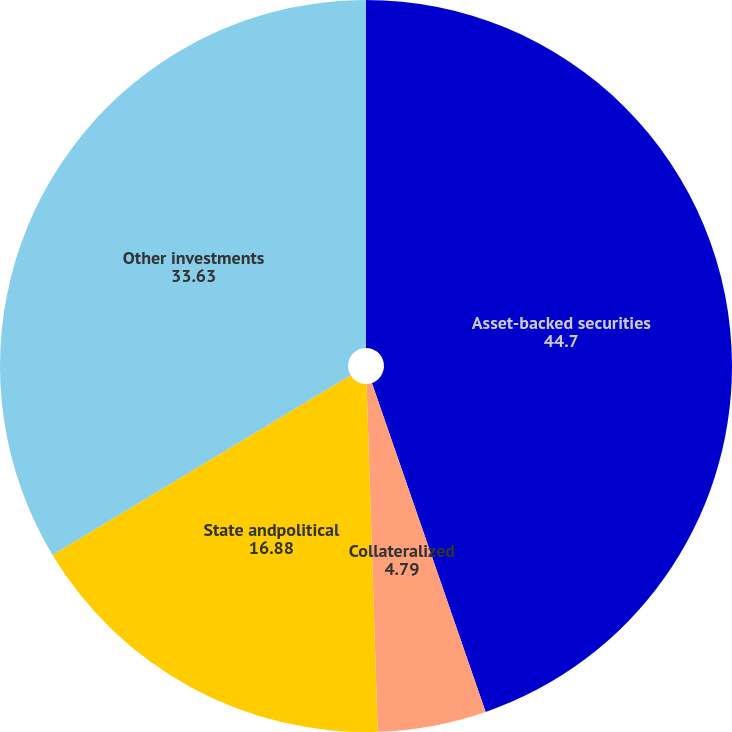<chart> <loc_0><loc_0><loc_500><loc_500><pie_chart><fcel>Asset-backed securities<fcel>Collateralized<fcel>State andpolitical<fcel>Other investments<nl><fcel>44.7%<fcel>4.79%<fcel>16.88%<fcel>33.63%<nl></chart> 